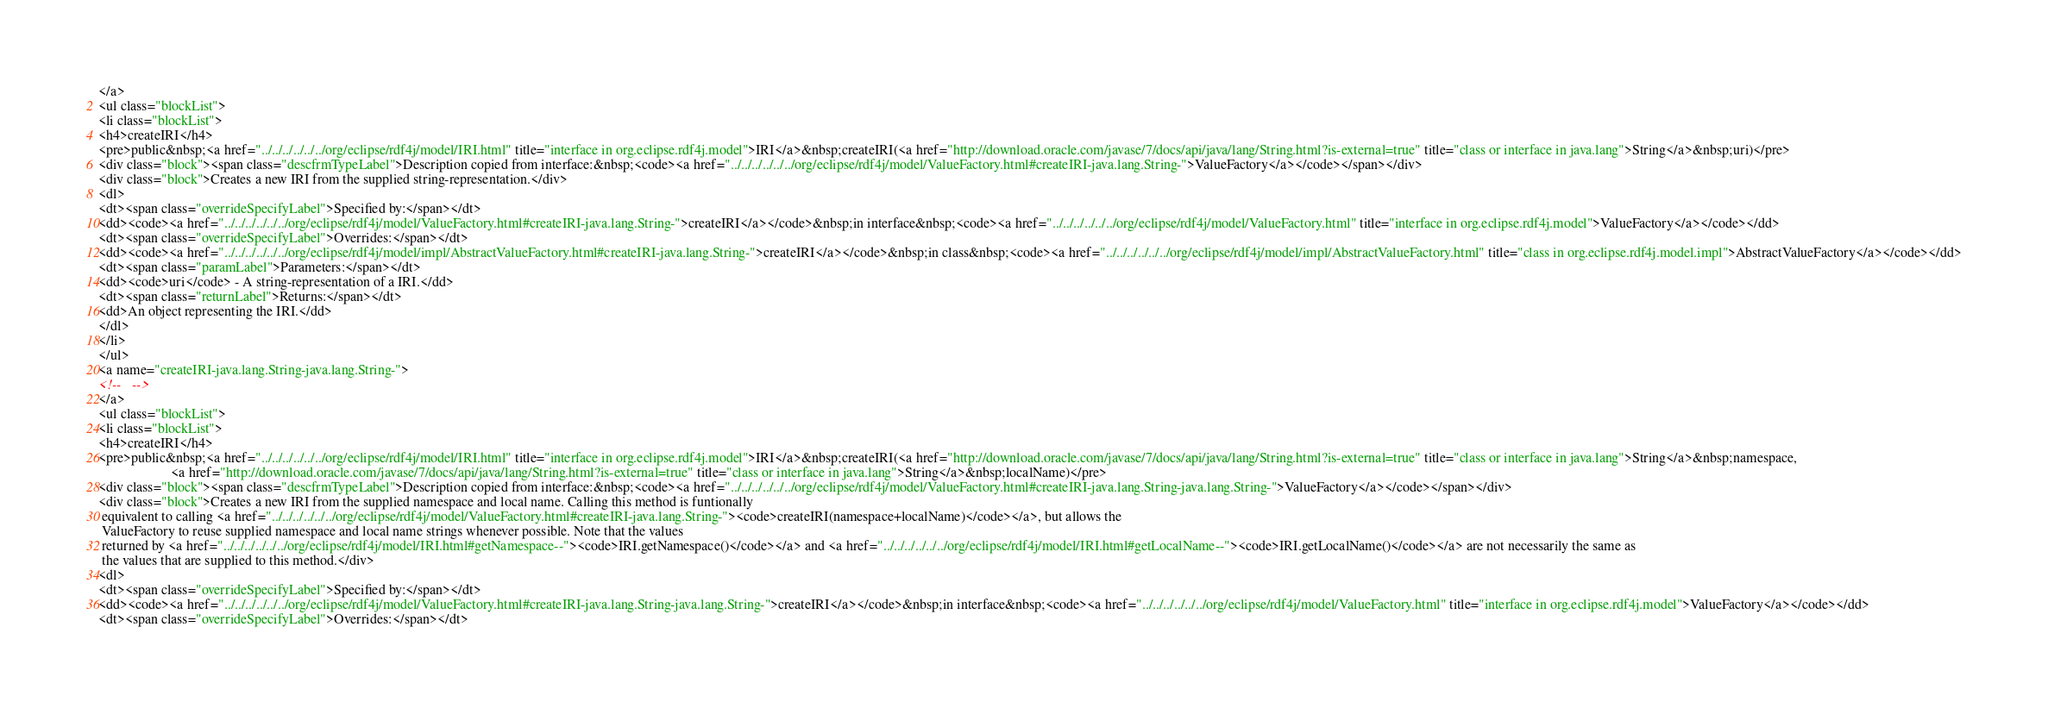Convert code to text. <code><loc_0><loc_0><loc_500><loc_500><_HTML_></a>
<ul class="blockList">
<li class="blockList">
<h4>createIRI</h4>
<pre>public&nbsp;<a href="../../../../../../org/eclipse/rdf4j/model/IRI.html" title="interface in org.eclipse.rdf4j.model">IRI</a>&nbsp;createIRI(<a href="http://download.oracle.com/javase/7/docs/api/java/lang/String.html?is-external=true" title="class or interface in java.lang">String</a>&nbsp;uri)</pre>
<div class="block"><span class="descfrmTypeLabel">Description copied from interface:&nbsp;<code><a href="../../../../../../org/eclipse/rdf4j/model/ValueFactory.html#createIRI-java.lang.String-">ValueFactory</a></code></span></div>
<div class="block">Creates a new IRI from the supplied string-representation.</div>
<dl>
<dt><span class="overrideSpecifyLabel">Specified by:</span></dt>
<dd><code><a href="../../../../../../org/eclipse/rdf4j/model/ValueFactory.html#createIRI-java.lang.String-">createIRI</a></code>&nbsp;in interface&nbsp;<code><a href="../../../../../../org/eclipse/rdf4j/model/ValueFactory.html" title="interface in org.eclipse.rdf4j.model">ValueFactory</a></code></dd>
<dt><span class="overrideSpecifyLabel">Overrides:</span></dt>
<dd><code><a href="../../../../../../org/eclipse/rdf4j/model/impl/AbstractValueFactory.html#createIRI-java.lang.String-">createIRI</a></code>&nbsp;in class&nbsp;<code><a href="../../../../../../org/eclipse/rdf4j/model/impl/AbstractValueFactory.html" title="class in org.eclipse.rdf4j.model.impl">AbstractValueFactory</a></code></dd>
<dt><span class="paramLabel">Parameters:</span></dt>
<dd><code>uri</code> - A string-representation of a IRI.</dd>
<dt><span class="returnLabel">Returns:</span></dt>
<dd>An object representing the IRI.</dd>
</dl>
</li>
</ul>
<a name="createIRI-java.lang.String-java.lang.String-">
<!--   -->
</a>
<ul class="blockList">
<li class="blockList">
<h4>createIRI</h4>
<pre>public&nbsp;<a href="../../../../../../org/eclipse/rdf4j/model/IRI.html" title="interface in org.eclipse.rdf4j.model">IRI</a>&nbsp;createIRI(<a href="http://download.oracle.com/javase/7/docs/api/java/lang/String.html?is-external=true" title="class or interface in java.lang">String</a>&nbsp;namespace,
                     <a href="http://download.oracle.com/javase/7/docs/api/java/lang/String.html?is-external=true" title="class or interface in java.lang">String</a>&nbsp;localName)</pre>
<div class="block"><span class="descfrmTypeLabel">Description copied from interface:&nbsp;<code><a href="../../../../../../org/eclipse/rdf4j/model/ValueFactory.html#createIRI-java.lang.String-java.lang.String-">ValueFactory</a></code></span></div>
<div class="block">Creates a new IRI from the supplied namespace and local name. Calling this method is funtionally
 equivalent to calling <a href="../../../../../../org/eclipse/rdf4j/model/ValueFactory.html#createIRI-java.lang.String-"><code>createIRI(namespace+localName)</code></a>, but allows the
 ValueFactory to reuse supplied namespace and local name strings whenever possible. Note that the values
 returned by <a href="../../../../../../org/eclipse/rdf4j/model/IRI.html#getNamespace--"><code>IRI.getNamespace()</code></a> and <a href="../../../../../../org/eclipse/rdf4j/model/IRI.html#getLocalName--"><code>IRI.getLocalName()</code></a> are not necessarily the same as
 the values that are supplied to this method.</div>
<dl>
<dt><span class="overrideSpecifyLabel">Specified by:</span></dt>
<dd><code><a href="../../../../../../org/eclipse/rdf4j/model/ValueFactory.html#createIRI-java.lang.String-java.lang.String-">createIRI</a></code>&nbsp;in interface&nbsp;<code><a href="../../../../../../org/eclipse/rdf4j/model/ValueFactory.html" title="interface in org.eclipse.rdf4j.model">ValueFactory</a></code></dd>
<dt><span class="overrideSpecifyLabel">Overrides:</span></dt></code> 